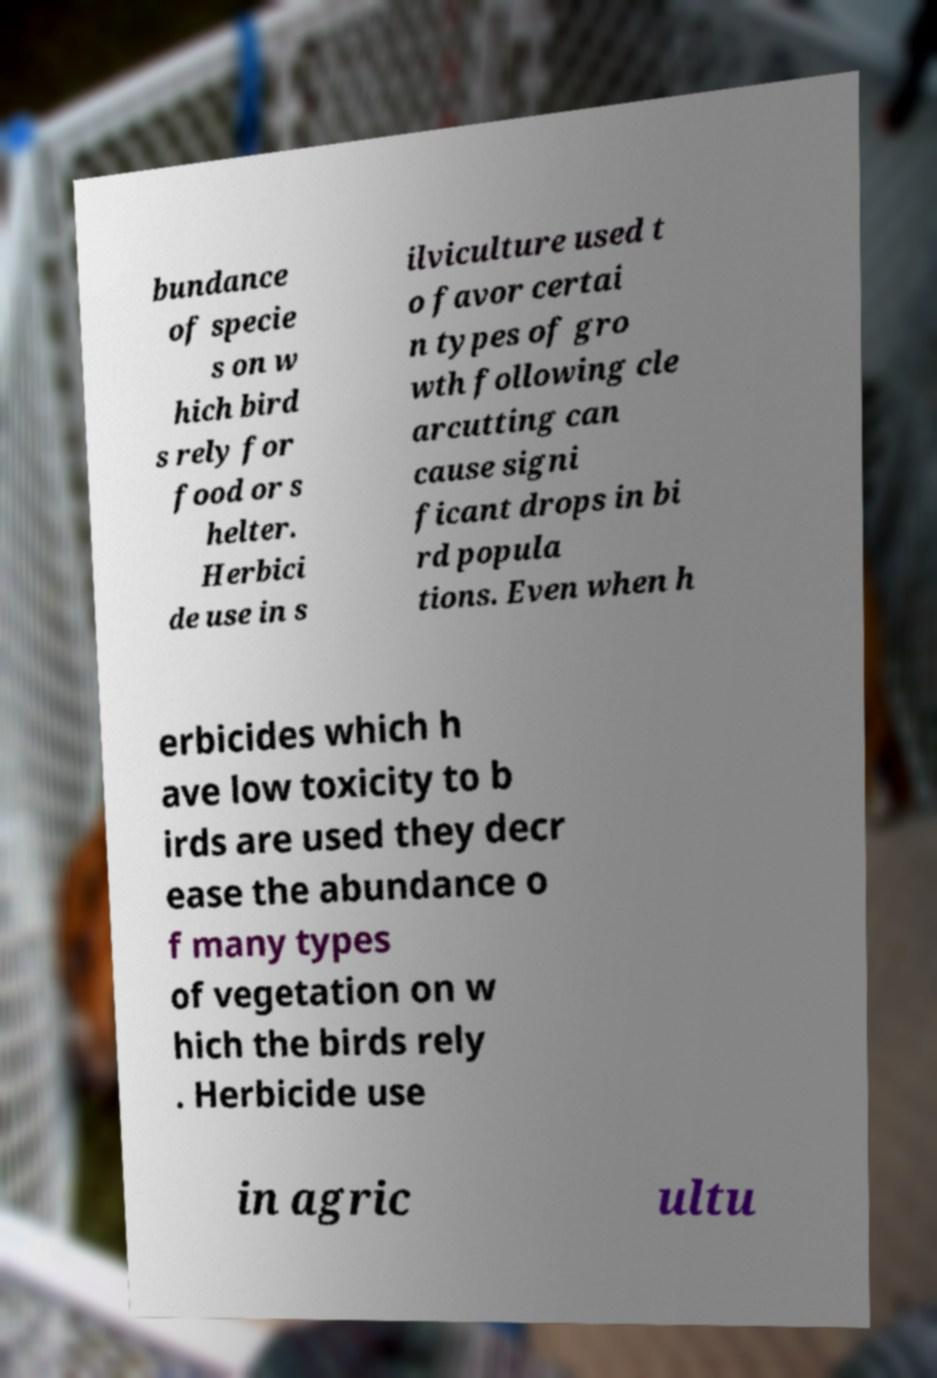Could you assist in decoding the text presented in this image and type it out clearly? bundance of specie s on w hich bird s rely for food or s helter. Herbici de use in s ilviculture used t o favor certai n types of gro wth following cle arcutting can cause signi ficant drops in bi rd popula tions. Even when h erbicides which h ave low toxicity to b irds are used they decr ease the abundance o f many types of vegetation on w hich the birds rely . Herbicide use in agric ultu 